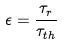<formula> <loc_0><loc_0><loc_500><loc_500>\epsilon = \frac { \tau _ { r } } { \tau _ { t h } }</formula> 